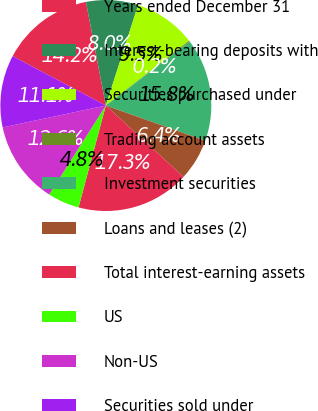Convert chart to OTSL. <chart><loc_0><loc_0><loc_500><loc_500><pie_chart><fcel>Years ended December 31<fcel>Interest-bearing deposits with<fcel>Securities purchased under<fcel>Trading account assets<fcel>Investment securities<fcel>Loans and leases (2)<fcel>Total interest-earning assets<fcel>US<fcel>Non-US<fcel>Securities sold under<nl><fcel>14.22%<fcel>7.97%<fcel>9.53%<fcel>0.16%<fcel>15.78%<fcel>6.41%<fcel>17.34%<fcel>4.85%<fcel>12.65%<fcel>11.09%<nl></chart> 